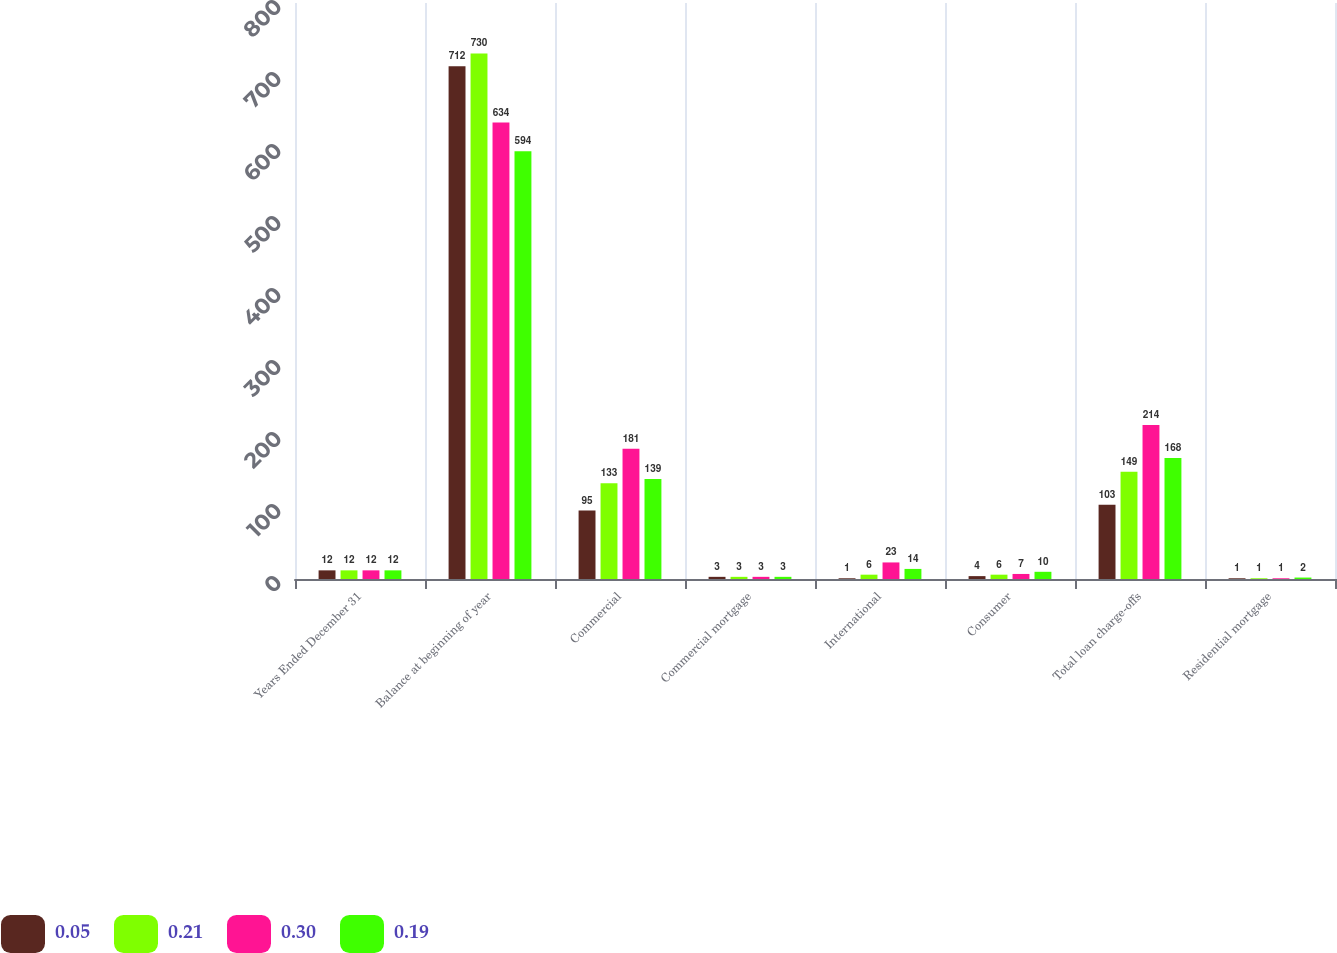<chart> <loc_0><loc_0><loc_500><loc_500><stacked_bar_chart><ecel><fcel>Years Ended December 31<fcel>Balance at beginning of year<fcel>Commercial<fcel>Commercial mortgage<fcel>International<fcel>Consumer<fcel>Total loan charge-offs<fcel>Residential mortgage<nl><fcel>0.05<fcel>12<fcel>712<fcel>95<fcel>3<fcel>1<fcel>4<fcel>103<fcel>1<nl><fcel>0.21<fcel>12<fcel>730<fcel>133<fcel>3<fcel>6<fcel>6<fcel>149<fcel>1<nl><fcel>0.3<fcel>12<fcel>634<fcel>181<fcel>3<fcel>23<fcel>7<fcel>214<fcel>1<nl><fcel>0.19<fcel>12<fcel>594<fcel>139<fcel>3<fcel>14<fcel>10<fcel>168<fcel>2<nl></chart> 